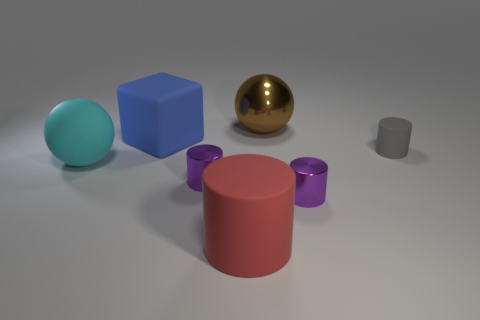How many other objects are there of the same shape as the brown thing?
Offer a terse response. 1. What number of gray things are large things or metallic spheres?
Offer a very short reply. 0. There is a metal cylinder on the left side of the big cylinder; is its color the same as the large cylinder?
Your response must be concise. No. There is a cyan thing that is the same material as the large cylinder; what is its shape?
Your answer should be compact. Sphere. There is a big object that is behind the gray cylinder and left of the brown ball; what color is it?
Provide a succinct answer. Blue. How big is the purple shiny cylinder on the left side of the matte cylinder that is in front of the gray matte cylinder?
Provide a succinct answer. Small. Is the number of purple metal cylinders right of the gray object the same as the number of big gray rubber balls?
Provide a succinct answer. Yes. What number of big cylinders are there?
Provide a short and direct response. 1. What is the shape of the tiny object that is to the right of the brown thing and in front of the gray thing?
Provide a succinct answer. Cylinder. There is a ball on the left side of the big blue cube; does it have the same color as the rubber cylinder that is in front of the cyan object?
Ensure brevity in your answer.  No. 